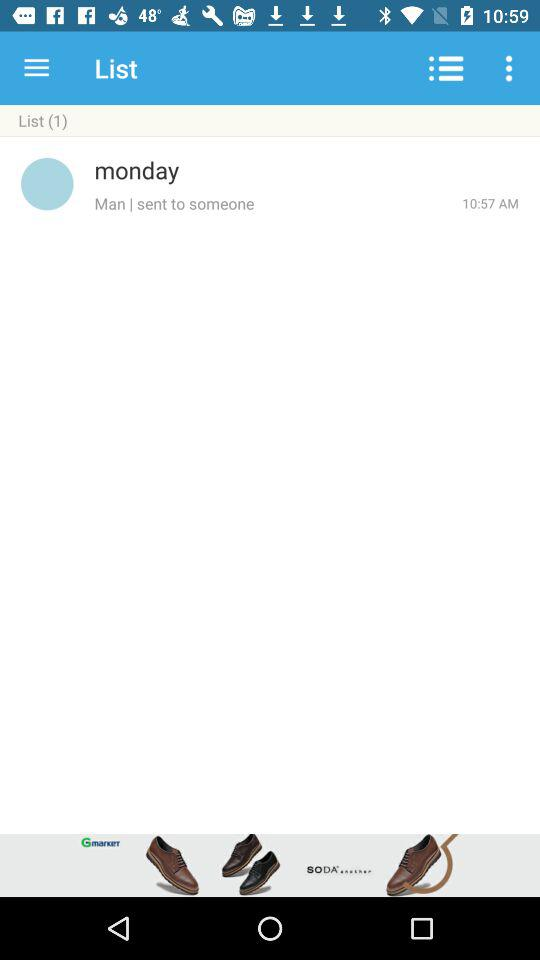What day is it? The day is Monday. 